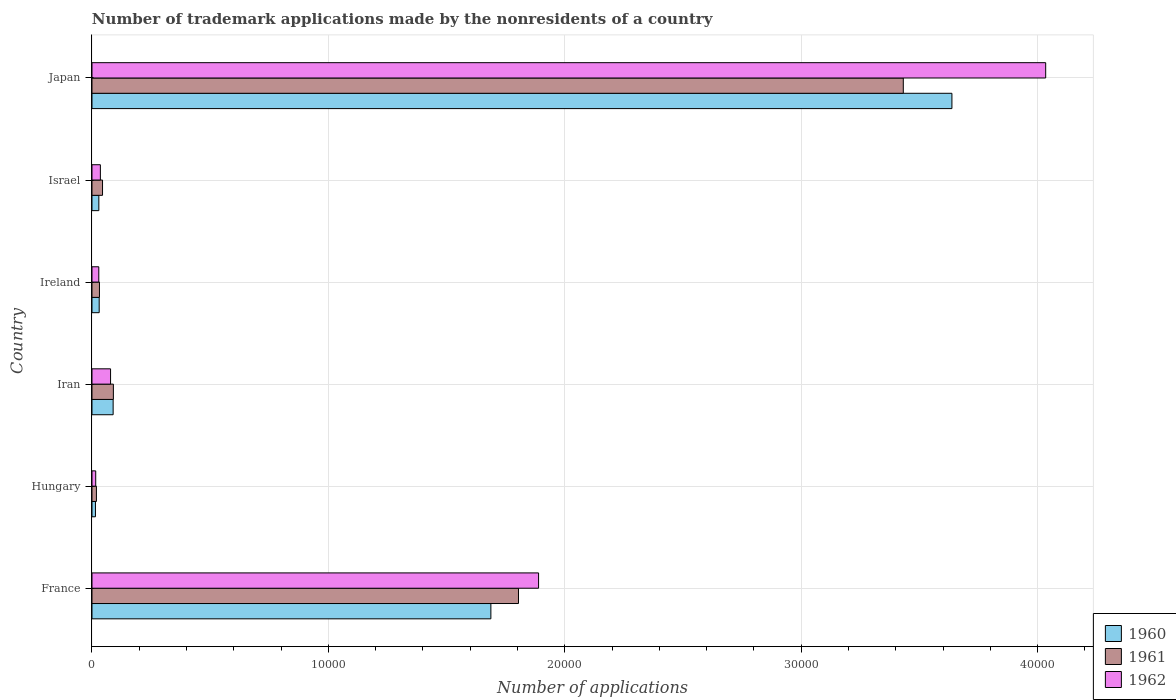How many different coloured bars are there?
Offer a terse response. 3. How many groups of bars are there?
Your response must be concise. 6. Are the number of bars per tick equal to the number of legend labels?
Offer a very short reply. Yes. What is the label of the 4th group of bars from the top?
Provide a succinct answer. Iran. In how many cases, is the number of bars for a given country not equal to the number of legend labels?
Make the answer very short. 0. What is the number of trademark applications made by the nonresidents in 1961 in Hungary?
Your response must be concise. 188. Across all countries, what is the maximum number of trademark applications made by the nonresidents in 1961?
Make the answer very short. 3.43e+04. Across all countries, what is the minimum number of trademark applications made by the nonresidents in 1961?
Keep it short and to the point. 188. In which country was the number of trademark applications made by the nonresidents in 1962 maximum?
Provide a short and direct response. Japan. In which country was the number of trademark applications made by the nonresidents in 1961 minimum?
Provide a succinct answer. Hungary. What is the total number of trademark applications made by the nonresidents in 1962 in the graph?
Provide a short and direct response. 6.08e+04. What is the difference between the number of trademark applications made by the nonresidents in 1962 in Hungary and that in Iran?
Your answer should be very brief. -628. What is the difference between the number of trademark applications made by the nonresidents in 1960 in Israel and the number of trademark applications made by the nonresidents in 1962 in Ireland?
Give a very brief answer. 2. What is the average number of trademark applications made by the nonresidents in 1961 per country?
Your answer should be very brief. 9036.17. What is the difference between the number of trademark applications made by the nonresidents in 1961 and number of trademark applications made by the nonresidents in 1962 in Japan?
Make the answer very short. -6023. What is the ratio of the number of trademark applications made by the nonresidents in 1962 in Hungary to that in Ireland?
Your answer should be very brief. 0.55. Is the difference between the number of trademark applications made by the nonresidents in 1961 in France and Israel greater than the difference between the number of trademark applications made by the nonresidents in 1962 in France and Israel?
Offer a very short reply. No. What is the difference between the highest and the second highest number of trademark applications made by the nonresidents in 1961?
Offer a very short reply. 1.63e+04. What is the difference between the highest and the lowest number of trademark applications made by the nonresidents in 1962?
Keep it short and to the point. 4.02e+04. In how many countries, is the number of trademark applications made by the nonresidents in 1962 greater than the average number of trademark applications made by the nonresidents in 1962 taken over all countries?
Make the answer very short. 2. What does the 3rd bar from the top in France represents?
Offer a terse response. 1960. What does the 1st bar from the bottom in Israel represents?
Your response must be concise. 1960. Are all the bars in the graph horizontal?
Keep it short and to the point. Yes. Does the graph contain any zero values?
Your answer should be very brief. No. How many legend labels are there?
Keep it short and to the point. 3. How are the legend labels stacked?
Ensure brevity in your answer.  Vertical. What is the title of the graph?
Offer a terse response. Number of trademark applications made by the nonresidents of a country. Does "1976" appear as one of the legend labels in the graph?
Your response must be concise. No. What is the label or title of the X-axis?
Your answer should be very brief. Number of applications. What is the Number of applications of 1960 in France?
Your response must be concise. 1.69e+04. What is the Number of applications in 1961 in France?
Offer a very short reply. 1.80e+04. What is the Number of applications in 1962 in France?
Make the answer very short. 1.89e+04. What is the Number of applications in 1960 in Hungary?
Provide a short and direct response. 147. What is the Number of applications of 1961 in Hungary?
Your answer should be compact. 188. What is the Number of applications in 1962 in Hungary?
Your answer should be very brief. 158. What is the Number of applications in 1960 in Iran?
Offer a very short reply. 895. What is the Number of applications in 1961 in Iran?
Make the answer very short. 905. What is the Number of applications of 1962 in Iran?
Your response must be concise. 786. What is the Number of applications of 1960 in Ireland?
Provide a short and direct response. 305. What is the Number of applications of 1961 in Ireland?
Give a very brief answer. 316. What is the Number of applications of 1962 in Ireland?
Your response must be concise. 288. What is the Number of applications of 1960 in Israel?
Offer a terse response. 290. What is the Number of applications in 1961 in Israel?
Offer a very short reply. 446. What is the Number of applications of 1962 in Israel?
Your answer should be very brief. 355. What is the Number of applications in 1960 in Japan?
Make the answer very short. 3.64e+04. What is the Number of applications of 1961 in Japan?
Keep it short and to the point. 3.43e+04. What is the Number of applications in 1962 in Japan?
Ensure brevity in your answer.  4.03e+04. Across all countries, what is the maximum Number of applications in 1960?
Your answer should be compact. 3.64e+04. Across all countries, what is the maximum Number of applications of 1961?
Give a very brief answer. 3.43e+04. Across all countries, what is the maximum Number of applications of 1962?
Make the answer very short. 4.03e+04. Across all countries, what is the minimum Number of applications of 1960?
Provide a short and direct response. 147. Across all countries, what is the minimum Number of applications of 1961?
Provide a short and direct response. 188. Across all countries, what is the minimum Number of applications in 1962?
Offer a terse response. 158. What is the total Number of applications in 1960 in the graph?
Ensure brevity in your answer.  5.49e+04. What is the total Number of applications of 1961 in the graph?
Your answer should be very brief. 5.42e+04. What is the total Number of applications of 1962 in the graph?
Give a very brief answer. 6.08e+04. What is the difference between the Number of applications of 1960 in France and that in Hungary?
Provide a succinct answer. 1.67e+04. What is the difference between the Number of applications in 1961 in France and that in Hungary?
Offer a very short reply. 1.79e+04. What is the difference between the Number of applications in 1962 in France and that in Hungary?
Your answer should be compact. 1.87e+04. What is the difference between the Number of applications in 1960 in France and that in Iran?
Your response must be concise. 1.60e+04. What is the difference between the Number of applications of 1961 in France and that in Iran?
Keep it short and to the point. 1.71e+04. What is the difference between the Number of applications in 1962 in France and that in Iran?
Provide a succinct answer. 1.81e+04. What is the difference between the Number of applications in 1960 in France and that in Ireland?
Your response must be concise. 1.66e+04. What is the difference between the Number of applications of 1961 in France and that in Ireland?
Give a very brief answer. 1.77e+04. What is the difference between the Number of applications in 1962 in France and that in Ireland?
Your answer should be compact. 1.86e+04. What is the difference between the Number of applications of 1960 in France and that in Israel?
Your response must be concise. 1.66e+04. What is the difference between the Number of applications in 1961 in France and that in Israel?
Provide a succinct answer. 1.76e+04. What is the difference between the Number of applications in 1962 in France and that in Israel?
Keep it short and to the point. 1.85e+04. What is the difference between the Number of applications in 1960 in France and that in Japan?
Make the answer very short. -1.95e+04. What is the difference between the Number of applications in 1961 in France and that in Japan?
Your response must be concise. -1.63e+04. What is the difference between the Number of applications of 1962 in France and that in Japan?
Offer a very short reply. -2.15e+04. What is the difference between the Number of applications in 1960 in Hungary and that in Iran?
Give a very brief answer. -748. What is the difference between the Number of applications in 1961 in Hungary and that in Iran?
Your answer should be very brief. -717. What is the difference between the Number of applications of 1962 in Hungary and that in Iran?
Your response must be concise. -628. What is the difference between the Number of applications of 1960 in Hungary and that in Ireland?
Your answer should be very brief. -158. What is the difference between the Number of applications in 1961 in Hungary and that in Ireland?
Offer a terse response. -128. What is the difference between the Number of applications of 1962 in Hungary and that in Ireland?
Ensure brevity in your answer.  -130. What is the difference between the Number of applications of 1960 in Hungary and that in Israel?
Ensure brevity in your answer.  -143. What is the difference between the Number of applications in 1961 in Hungary and that in Israel?
Your response must be concise. -258. What is the difference between the Number of applications of 1962 in Hungary and that in Israel?
Give a very brief answer. -197. What is the difference between the Number of applications of 1960 in Hungary and that in Japan?
Keep it short and to the point. -3.62e+04. What is the difference between the Number of applications in 1961 in Hungary and that in Japan?
Your answer should be very brief. -3.41e+04. What is the difference between the Number of applications in 1962 in Hungary and that in Japan?
Offer a terse response. -4.02e+04. What is the difference between the Number of applications of 1960 in Iran and that in Ireland?
Ensure brevity in your answer.  590. What is the difference between the Number of applications in 1961 in Iran and that in Ireland?
Offer a very short reply. 589. What is the difference between the Number of applications in 1962 in Iran and that in Ireland?
Your answer should be compact. 498. What is the difference between the Number of applications in 1960 in Iran and that in Israel?
Your answer should be compact. 605. What is the difference between the Number of applications of 1961 in Iran and that in Israel?
Your response must be concise. 459. What is the difference between the Number of applications in 1962 in Iran and that in Israel?
Offer a very short reply. 431. What is the difference between the Number of applications in 1960 in Iran and that in Japan?
Your answer should be compact. -3.55e+04. What is the difference between the Number of applications of 1961 in Iran and that in Japan?
Your response must be concise. -3.34e+04. What is the difference between the Number of applications of 1962 in Iran and that in Japan?
Ensure brevity in your answer.  -3.96e+04. What is the difference between the Number of applications of 1961 in Ireland and that in Israel?
Ensure brevity in your answer.  -130. What is the difference between the Number of applications of 1962 in Ireland and that in Israel?
Give a very brief answer. -67. What is the difference between the Number of applications of 1960 in Ireland and that in Japan?
Ensure brevity in your answer.  -3.61e+04. What is the difference between the Number of applications of 1961 in Ireland and that in Japan?
Provide a succinct answer. -3.40e+04. What is the difference between the Number of applications in 1962 in Ireland and that in Japan?
Your response must be concise. -4.01e+04. What is the difference between the Number of applications in 1960 in Israel and that in Japan?
Provide a short and direct response. -3.61e+04. What is the difference between the Number of applications of 1961 in Israel and that in Japan?
Your response must be concise. -3.39e+04. What is the difference between the Number of applications of 1962 in Israel and that in Japan?
Offer a very short reply. -4.00e+04. What is the difference between the Number of applications of 1960 in France and the Number of applications of 1961 in Hungary?
Keep it short and to the point. 1.67e+04. What is the difference between the Number of applications of 1960 in France and the Number of applications of 1962 in Hungary?
Your answer should be compact. 1.67e+04. What is the difference between the Number of applications of 1961 in France and the Number of applications of 1962 in Hungary?
Offer a very short reply. 1.79e+04. What is the difference between the Number of applications in 1960 in France and the Number of applications in 1961 in Iran?
Your answer should be compact. 1.60e+04. What is the difference between the Number of applications of 1960 in France and the Number of applications of 1962 in Iran?
Your response must be concise. 1.61e+04. What is the difference between the Number of applications in 1961 in France and the Number of applications in 1962 in Iran?
Your answer should be compact. 1.73e+04. What is the difference between the Number of applications of 1960 in France and the Number of applications of 1961 in Ireland?
Provide a short and direct response. 1.66e+04. What is the difference between the Number of applications in 1960 in France and the Number of applications in 1962 in Ireland?
Your answer should be compact. 1.66e+04. What is the difference between the Number of applications of 1961 in France and the Number of applications of 1962 in Ireland?
Offer a very short reply. 1.78e+04. What is the difference between the Number of applications of 1960 in France and the Number of applications of 1961 in Israel?
Your response must be concise. 1.64e+04. What is the difference between the Number of applications of 1960 in France and the Number of applications of 1962 in Israel?
Offer a terse response. 1.65e+04. What is the difference between the Number of applications of 1961 in France and the Number of applications of 1962 in Israel?
Your answer should be very brief. 1.77e+04. What is the difference between the Number of applications in 1960 in France and the Number of applications in 1961 in Japan?
Offer a very short reply. -1.74e+04. What is the difference between the Number of applications of 1960 in France and the Number of applications of 1962 in Japan?
Provide a short and direct response. -2.35e+04. What is the difference between the Number of applications in 1961 in France and the Number of applications in 1962 in Japan?
Offer a terse response. -2.23e+04. What is the difference between the Number of applications of 1960 in Hungary and the Number of applications of 1961 in Iran?
Provide a short and direct response. -758. What is the difference between the Number of applications in 1960 in Hungary and the Number of applications in 1962 in Iran?
Offer a very short reply. -639. What is the difference between the Number of applications of 1961 in Hungary and the Number of applications of 1962 in Iran?
Provide a succinct answer. -598. What is the difference between the Number of applications of 1960 in Hungary and the Number of applications of 1961 in Ireland?
Provide a succinct answer. -169. What is the difference between the Number of applications of 1960 in Hungary and the Number of applications of 1962 in Ireland?
Your answer should be very brief. -141. What is the difference between the Number of applications in 1961 in Hungary and the Number of applications in 1962 in Ireland?
Your answer should be compact. -100. What is the difference between the Number of applications of 1960 in Hungary and the Number of applications of 1961 in Israel?
Your answer should be compact. -299. What is the difference between the Number of applications in 1960 in Hungary and the Number of applications in 1962 in Israel?
Your answer should be compact. -208. What is the difference between the Number of applications in 1961 in Hungary and the Number of applications in 1962 in Israel?
Your answer should be compact. -167. What is the difference between the Number of applications in 1960 in Hungary and the Number of applications in 1961 in Japan?
Offer a terse response. -3.42e+04. What is the difference between the Number of applications of 1960 in Hungary and the Number of applications of 1962 in Japan?
Offer a terse response. -4.02e+04. What is the difference between the Number of applications of 1961 in Hungary and the Number of applications of 1962 in Japan?
Offer a very short reply. -4.02e+04. What is the difference between the Number of applications in 1960 in Iran and the Number of applications in 1961 in Ireland?
Your response must be concise. 579. What is the difference between the Number of applications of 1960 in Iran and the Number of applications of 1962 in Ireland?
Keep it short and to the point. 607. What is the difference between the Number of applications of 1961 in Iran and the Number of applications of 1962 in Ireland?
Keep it short and to the point. 617. What is the difference between the Number of applications of 1960 in Iran and the Number of applications of 1961 in Israel?
Make the answer very short. 449. What is the difference between the Number of applications of 1960 in Iran and the Number of applications of 1962 in Israel?
Provide a short and direct response. 540. What is the difference between the Number of applications in 1961 in Iran and the Number of applications in 1962 in Israel?
Make the answer very short. 550. What is the difference between the Number of applications in 1960 in Iran and the Number of applications in 1961 in Japan?
Your answer should be compact. -3.34e+04. What is the difference between the Number of applications in 1960 in Iran and the Number of applications in 1962 in Japan?
Your answer should be very brief. -3.94e+04. What is the difference between the Number of applications in 1961 in Iran and the Number of applications in 1962 in Japan?
Provide a short and direct response. -3.94e+04. What is the difference between the Number of applications in 1960 in Ireland and the Number of applications in 1961 in Israel?
Give a very brief answer. -141. What is the difference between the Number of applications of 1961 in Ireland and the Number of applications of 1962 in Israel?
Your answer should be very brief. -39. What is the difference between the Number of applications of 1960 in Ireland and the Number of applications of 1961 in Japan?
Provide a succinct answer. -3.40e+04. What is the difference between the Number of applications in 1960 in Ireland and the Number of applications in 1962 in Japan?
Offer a very short reply. -4.00e+04. What is the difference between the Number of applications in 1961 in Ireland and the Number of applications in 1962 in Japan?
Give a very brief answer. -4.00e+04. What is the difference between the Number of applications in 1960 in Israel and the Number of applications in 1961 in Japan?
Offer a terse response. -3.40e+04. What is the difference between the Number of applications in 1960 in Israel and the Number of applications in 1962 in Japan?
Give a very brief answer. -4.01e+04. What is the difference between the Number of applications of 1961 in Israel and the Number of applications of 1962 in Japan?
Provide a succinct answer. -3.99e+04. What is the average Number of applications in 1960 per country?
Your answer should be very brief. 9148. What is the average Number of applications in 1961 per country?
Your response must be concise. 9036.17. What is the average Number of applications of 1962 per country?
Offer a terse response. 1.01e+04. What is the difference between the Number of applications of 1960 and Number of applications of 1961 in France?
Provide a succinct answer. -1168. What is the difference between the Number of applications of 1960 and Number of applications of 1962 in France?
Provide a short and direct response. -2018. What is the difference between the Number of applications in 1961 and Number of applications in 1962 in France?
Keep it short and to the point. -850. What is the difference between the Number of applications in 1960 and Number of applications in 1961 in Hungary?
Provide a short and direct response. -41. What is the difference between the Number of applications in 1960 and Number of applications in 1962 in Hungary?
Your answer should be very brief. -11. What is the difference between the Number of applications in 1960 and Number of applications in 1962 in Iran?
Make the answer very short. 109. What is the difference between the Number of applications in 1961 and Number of applications in 1962 in Iran?
Offer a very short reply. 119. What is the difference between the Number of applications of 1960 and Number of applications of 1961 in Ireland?
Give a very brief answer. -11. What is the difference between the Number of applications of 1961 and Number of applications of 1962 in Ireland?
Your answer should be very brief. 28. What is the difference between the Number of applications in 1960 and Number of applications in 1961 in Israel?
Provide a short and direct response. -156. What is the difference between the Number of applications of 1960 and Number of applications of 1962 in Israel?
Your answer should be compact. -65. What is the difference between the Number of applications in 1961 and Number of applications in 1962 in Israel?
Give a very brief answer. 91. What is the difference between the Number of applications of 1960 and Number of applications of 1961 in Japan?
Your response must be concise. 2057. What is the difference between the Number of applications of 1960 and Number of applications of 1962 in Japan?
Offer a very short reply. -3966. What is the difference between the Number of applications in 1961 and Number of applications in 1962 in Japan?
Give a very brief answer. -6023. What is the ratio of the Number of applications of 1960 in France to that in Hungary?
Your answer should be very brief. 114.79. What is the ratio of the Number of applications of 1961 in France to that in Hungary?
Offer a terse response. 95.97. What is the ratio of the Number of applications of 1962 in France to that in Hungary?
Make the answer very short. 119.57. What is the ratio of the Number of applications in 1960 in France to that in Iran?
Ensure brevity in your answer.  18.85. What is the ratio of the Number of applications in 1961 in France to that in Iran?
Give a very brief answer. 19.94. What is the ratio of the Number of applications in 1962 in France to that in Iran?
Provide a succinct answer. 24.04. What is the ratio of the Number of applications of 1960 in France to that in Ireland?
Ensure brevity in your answer.  55.32. What is the ratio of the Number of applications in 1961 in France to that in Ireland?
Ensure brevity in your answer.  57.09. What is the ratio of the Number of applications in 1962 in France to that in Ireland?
Keep it short and to the point. 65.6. What is the ratio of the Number of applications of 1960 in France to that in Israel?
Provide a short and direct response. 58.19. What is the ratio of the Number of applications of 1961 in France to that in Israel?
Your answer should be very brief. 40.45. What is the ratio of the Number of applications of 1962 in France to that in Israel?
Provide a succinct answer. 53.22. What is the ratio of the Number of applications in 1960 in France to that in Japan?
Your response must be concise. 0.46. What is the ratio of the Number of applications in 1961 in France to that in Japan?
Offer a terse response. 0.53. What is the ratio of the Number of applications of 1962 in France to that in Japan?
Offer a terse response. 0.47. What is the ratio of the Number of applications of 1960 in Hungary to that in Iran?
Give a very brief answer. 0.16. What is the ratio of the Number of applications in 1961 in Hungary to that in Iran?
Your response must be concise. 0.21. What is the ratio of the Number of applications in 1962 in Hungary to that in Iran?
Your response must be concise. 0.2. What is the ratio of the Number of applications in 1960 in Hungary to that in Ireland?
Your answer should be very brief. 0.48. What is the ratio of the Number of applications of 1961 in Hungary to that in Ireland?
Make the answer very short. 0.59. What is the ratio of the Number of applications of 1962 in Hungary to that in Ireland?
Offer a very short reply. 0.55. What is the ratio of the Number of applications in 1960 in Hungary to that in Israel?
Ensure brevity in your answer.  0.51. What is the ratio of the Number of applications in 1961 in Hungary to that in Israel?
Keep it short and to the point. 0.42. What is the ratio of the Number of applications of 1962 in Hungary to that in Israel?
Offer a terse response. 0.45. What is the ratio of the Number of applications in 1960 in Hungary to that in Japan?
Offer a very short reply. 0. What is the ratio of the Number of applications in 1961 in Hungary to that in Japan?
Your answer should be very brief. 0.01. What is the ratio of the Number of applications in 1962 in Hungary to that in Japan?
Make the answer very short. 0. What is the ratio of the Number of applications in 1960 in Iran to that in Ireland?
Your answer should be very brief. 2.93. What is the ratio of the Number of applications in 1961 in Iran to that in Ireland?
Offer a terse response. 2.86. What is the ratio of the Number of applications of 1962 in Iran to that in Ireland?
Keep it short and to the point. 2.73. What is the ratio of the Number of applications in 1960 in Iran to that in Israel?
Your answer should be compact. 3.09. What is the ratio of the Number of applications of 1961 in Iran to that in Israel?
Your answer should be compact. 2.03. What is the ratio of the Number of applications in 1962 in Iran to that in Israel?
Give a very brief answer. 2.21. What is the ratio of the Number of applications of 1960 in Iran to that in Japan?
Provide a succinct answer. 0.02. What is the ratio of the Number of applications in 1961 in Iran to that in Japan?
Your answer should be very brief. 0.03. What is the ratio of the Number of applications in 1962 in Iran to that in Japan?
Ensure brevity in your answer.  0.02. What is the ratio of the Number of applications of 1960 in Ireland to that in Israel?
Offer a very short reply. 1.05. What is the ratio of the Number of applications in 1961 in Ireland to that in Israel?
Your response must be concise. 0.71. What is the ratio of the Number of applications in 1962 in Ireland to that in Israel?
Make the answer very short. 0.81. What is the ratio of the Number of applications of 1960 in Ireland to that in Japan?
Provide a succinct answer. 0.01. What is the ratio of the Number of applications in 1961 in Ireland to that in Japan?
Give a very brief answer. 0.01. What is the ratio of the Number of applications of 1962 in Ireland to that in Japan?
Provide a short and direct response. 0.01. What is the ratio of the Number of applications in 1960 in Israel to that in Japan?
Make the answer very short. 0.01. What is the ratio of the Number of applications of 1961 in Israel to that in Japan?
Give a very brief answer. 0.01. What is the ratio of the Number of applications in 1962 in Israel to that in Japan?
Your answer should be compact. 0.01. What is the difference between the highest and the second highest Number of applications in 1960?
Ensure brevity in your answer.  1.95e+04. What is the difference between the highest and the second highest Number of applications in 1961?
Offer a terse response. 1.63e+04. What is the difference between the highest and the second highest Number of applications in 1962?
Keep it short and to the point. 2.15e+04. What is the difference between the highest and the lowest Number of applications of 1960?
Give a very brief answer. 3.62e+04. What is the difference between the highest and the lowest Number of applications of 1961?
Keep it short and to the point. 3.41e+04. What is the difference between the highest and the lowest Number of applications of 1962?
Offer a very short reply. 4.02e+04. 